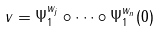Convert formula to latex. <formula><loc_0><loc_0><loc_500><loc_500>v = \Psi ^ { w _ { j } } _ { 1 } \circ \cdots \circ \Psi ^ { w _ { n } } _ { 1 } ( 0 )</formula> 